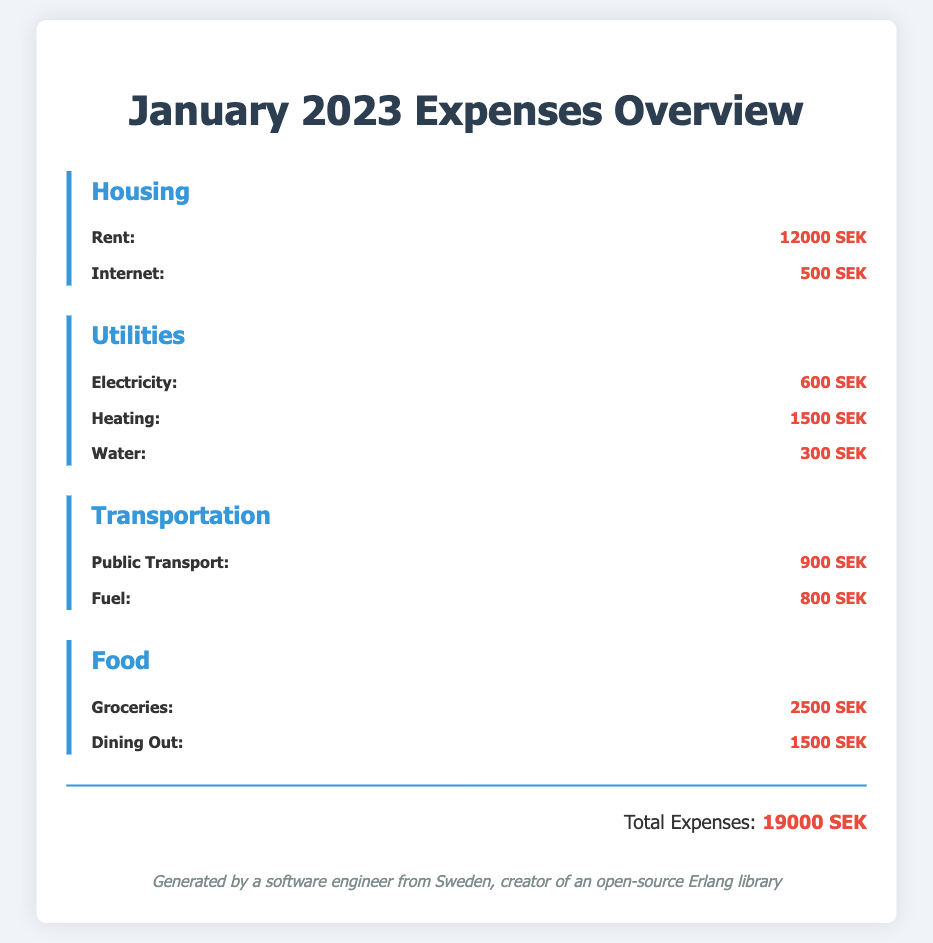What is the total expense for January 2023? The total expense is explicitly stated at the end of the document.
Answer: 19000 SEK How much is spent on rent? Rent is listed under the Housing category with its amount specified.
Answer: 12000 SEK What is the cost of internet service? The internet service cost is detailed in the Housing section.
Answer: 500 SEK How much is allocated for groceries? Groceries are listed under the Food category with a specific amount.
Answer: 2500 SEK What is the combined expense for utilities? The combined total for utilities needs to be calculated by summing all utility expenses listed.
Answer: 2400 SEK How much is spent on dining out? The amount for dining out is specified in the Food category.
Answer: 1500 SEK What is the expense for public transport? Public transport costs are specified in the Transportation section.
Answer: 900 SEK How much is paid for heating? The expense for heating is clearly mentioned in the Utilities category.
Answer: 1500 SEK What is the total for the Housing category? The total for Housing needs to be calculated by summing the listed expenses.
Answer: 12500 SEK 